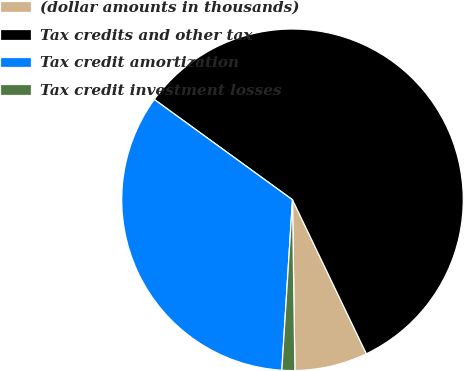Convert chart. <chart><loc_0><loc_0><loc_500><loc_500><pie_chart><fcel>(dollar amounts in thousands)<fcel>Tax credits and other tax<fcel>Tax credit amortization<fcel>Tax credit investment losses<nl><fcel>6.89%<fcel>57.89%<fcel>34.0%<fcel>1.22%<nl></chart> 